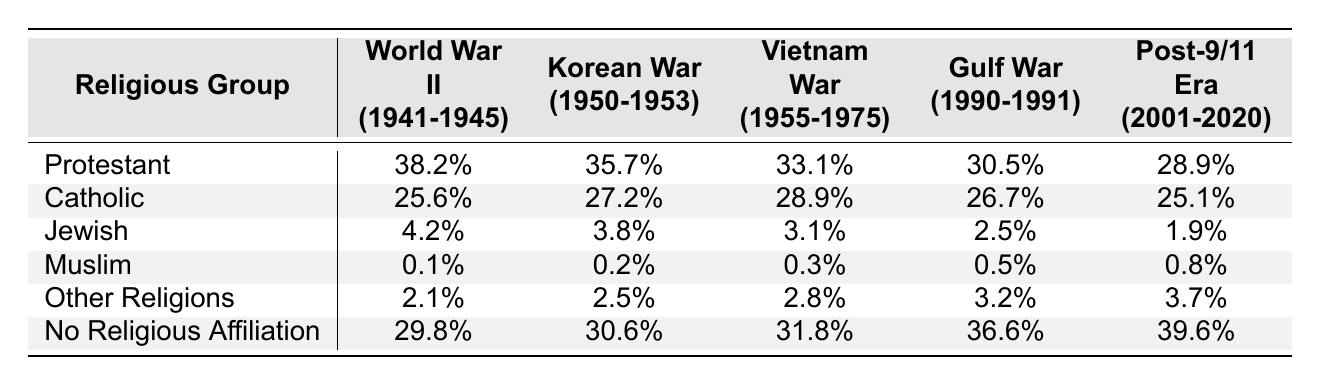What is the military service rate for Protestants during the Gulf War? According to the table, the military service rate for Protestants during the Gulf War (1990-1991) is listed as 30.5%.
Answer: 30.5% Which religious group had the highest military service rate in World War II? The table shows that Protestants had the highest military service rate during World War II (1941-1945) at 38.2%, compared to other groups listed.
Answer: Protestant What percentage of Muslims served in the military during the Post-9/11 Era? The table indicates that the military service rate for Muslims in the Post-9/11 Era (2001-2020) is 0.8%.
Answer: 0.8% How does the Catholic military service rate in the Korean War compare to the Vietnam War? The Korean War service rate for Catholics is 27.2%, while the Vietnam War service rate is 28.9%. Since 28.9% is greater than 27.2%, the Catholic rate was higher in the Vietnam War than in the Korean War.
Answer: Higher in the Vietnam War What is the difference in military service rates between Protestants in World War II and the Post-9/11 Era? The military service rate for Protestants in World War II is 38.2%, and in the Post-9/11 Era, it is 28.9%. The difference is 38.2% - 28.9% = 9.3%.
Answer: 9.3% Which group saw the largest increase in military service rates from the Gulf War to the Post-9/11 Era? The military service rate for 'No Religious Affiliation' increased from 36.6% in the Gulf War to 39.6% in the Post-9/11 Era, resulting in a 3% increase, which is larger than the other groups when comparing their respective rates.
Answer: No Religious Affiliation Is it true that the military service rate for Jewish individuals decreased in each conflict from World War II to the Post-9/11 Era? Upon examining the table, the rates for Jewish individuals are 4.2% (World War II), 3.8% (Korean War), 3.1% (Vietnam War), 2.5% (Gulf War), and 1.9% (Post-9/11 Era). Since all these values decline, it is true that their rates decreased in each conflict.
Answer: True What is the average military service rate for the religious groups listed during the Vietnam War? The service rates during the Vietnam War are: Protestant (33.1%), Catholic (28.9%), Jewish (3.1%), Muslim (0.3%), Other Religions (2.8%), and No Religious Affiliation (31.8%). The sum is 33.1 + 28.9 + 3.1 + 0.3 + 2.8 + 31.8 = 100.0%. Dividing by the number of groups (6) gives an average of 100.0% / 6 = 16.67%.
Answer: 16.67% What trend can be observed in the military service rates for Muslims from World War II to the Post-9/11 Era? The service rates for Muslims are: 0.1% (World War II), 0.2% (Korean War), 0.3% (Vietnam War), 0.5% (Gulf War), and 0.8% (Post-9/11 Era). There is a steady increase in their rates over these conflicts.
Answer: Steady increase Which religious group had the lowest military service rate during the Gulf War? The table shows that the Muslim group had the lowest military service rate during the Gulf War at 0.5%, compared to other groups listed for that conflict.
Answer: Muslim 